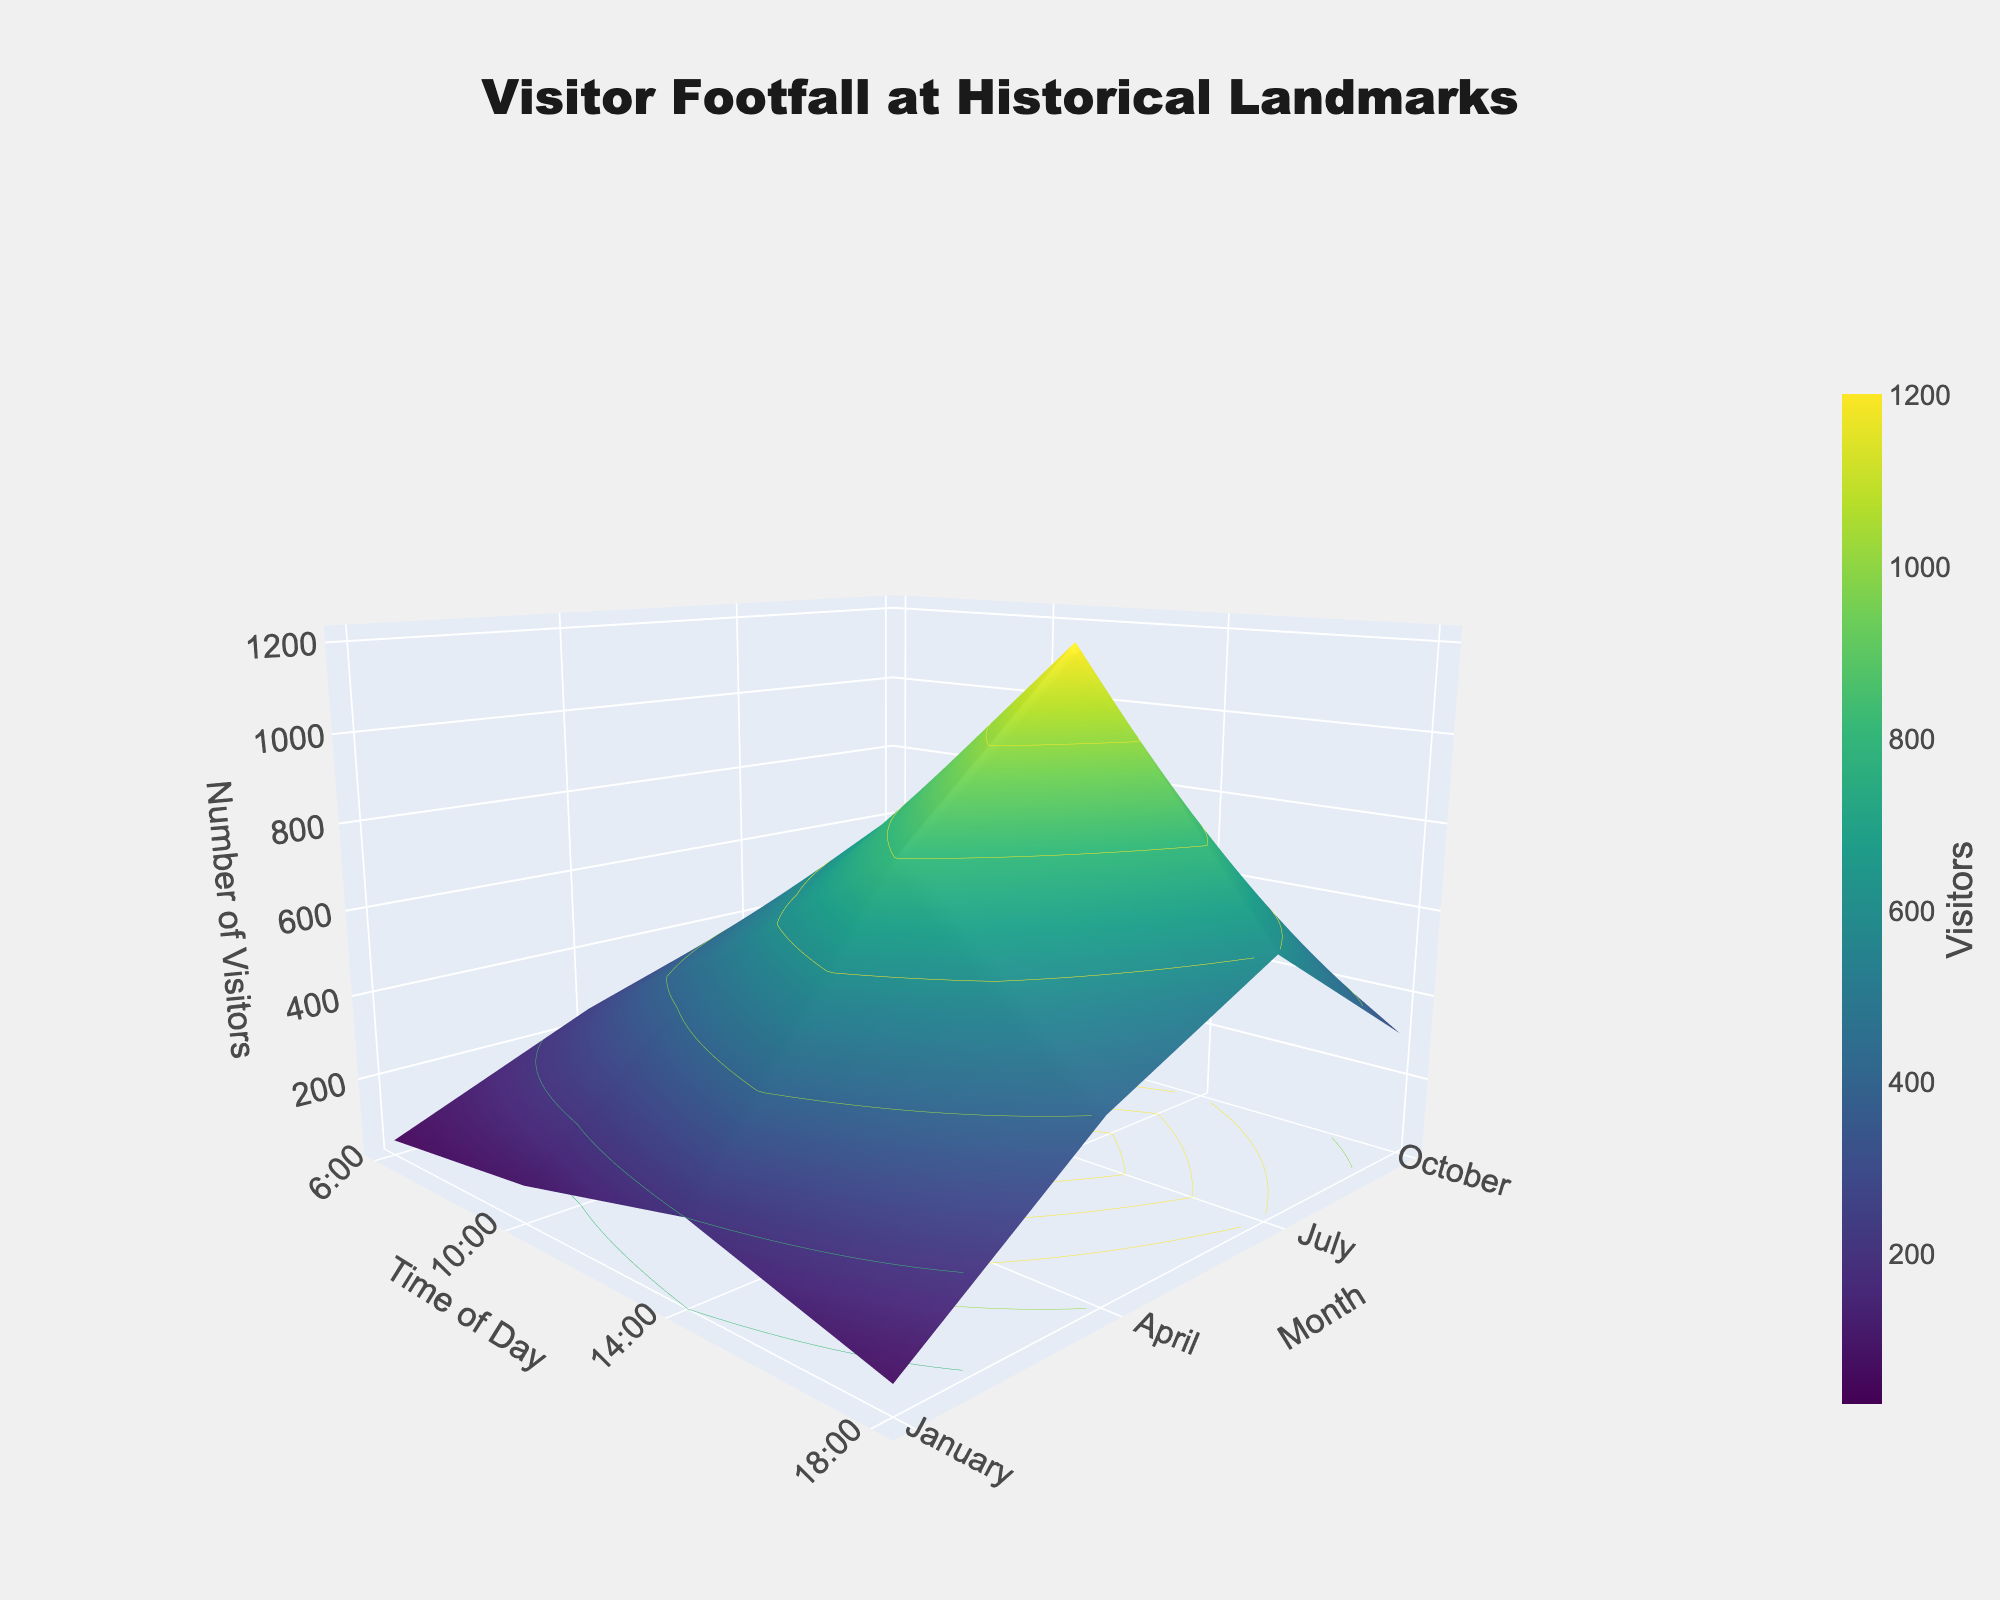What's the title of the figure? The title is clearly shown at the top of the figure. It is written in a prominent font and provides a summary of the data being displayed.
Answer: Visitor Footfall at Historical Landmarks What are the labels for the x, y, and z axes? The labels for the axes are displayed next to each axis. The x-axis is labeled "Time of Day," the y-axis is labeled "Month," and the z-axis is labeled "Number of Visitors."
Answer: Time of Day, Month, Number of Visitors During which month and time is the visitor footfall highest? To determine the highest footfall, look for the peak or highest point on the 3D surface plot. The highest peak is during July at 14:00.
Answer: July at 14:00 Compare the number of visitors at 10:00 in April and October. At which time is the footfall higher? Locate the heights of the 3D surface at 10:00 for both April and October. The height at 10:00 in April is higher than in October.
Answer: April What is the average number of visitors at 18:00 across all months? Sum the visitor numbers at 18:00 for all months and divide by the number of months. \( (200 + 400 + 600 + 300) / 4 = 375 \)
Answer: 375 Is there a significant drop in visitor footfall after 18:00? Compare the number of visitors at 18:00 with that at 22:00 across all months. All the values at 22:00 are significantly lower than at 18:00, indicating a drop.
Answer: Yes Which month shows the least variation in visitor footfall throughout the day? To find the month with the least variation, examine the range of visitor numbers throughout the day for each month. October shows a relatively smaller range compared to others.
Answer: October How does the visitor footfall at 6:00 in January compare to that at 6:00 in July? Compare the heights at 6:00 for January and July. January has 50 visitors, while July has 200 visitors, indicating that July has a higher footfall.
Answer: July In which month is the visitor footfall at 10:00 closest to the annual average at 10:00? Calculate the average number of visitors at 10:00 across all months: \( (250 + 500 + 800 + 400) / 4 = 487.5 \). The visitor footfall in October (400) is closest to this average.
Answer: October 